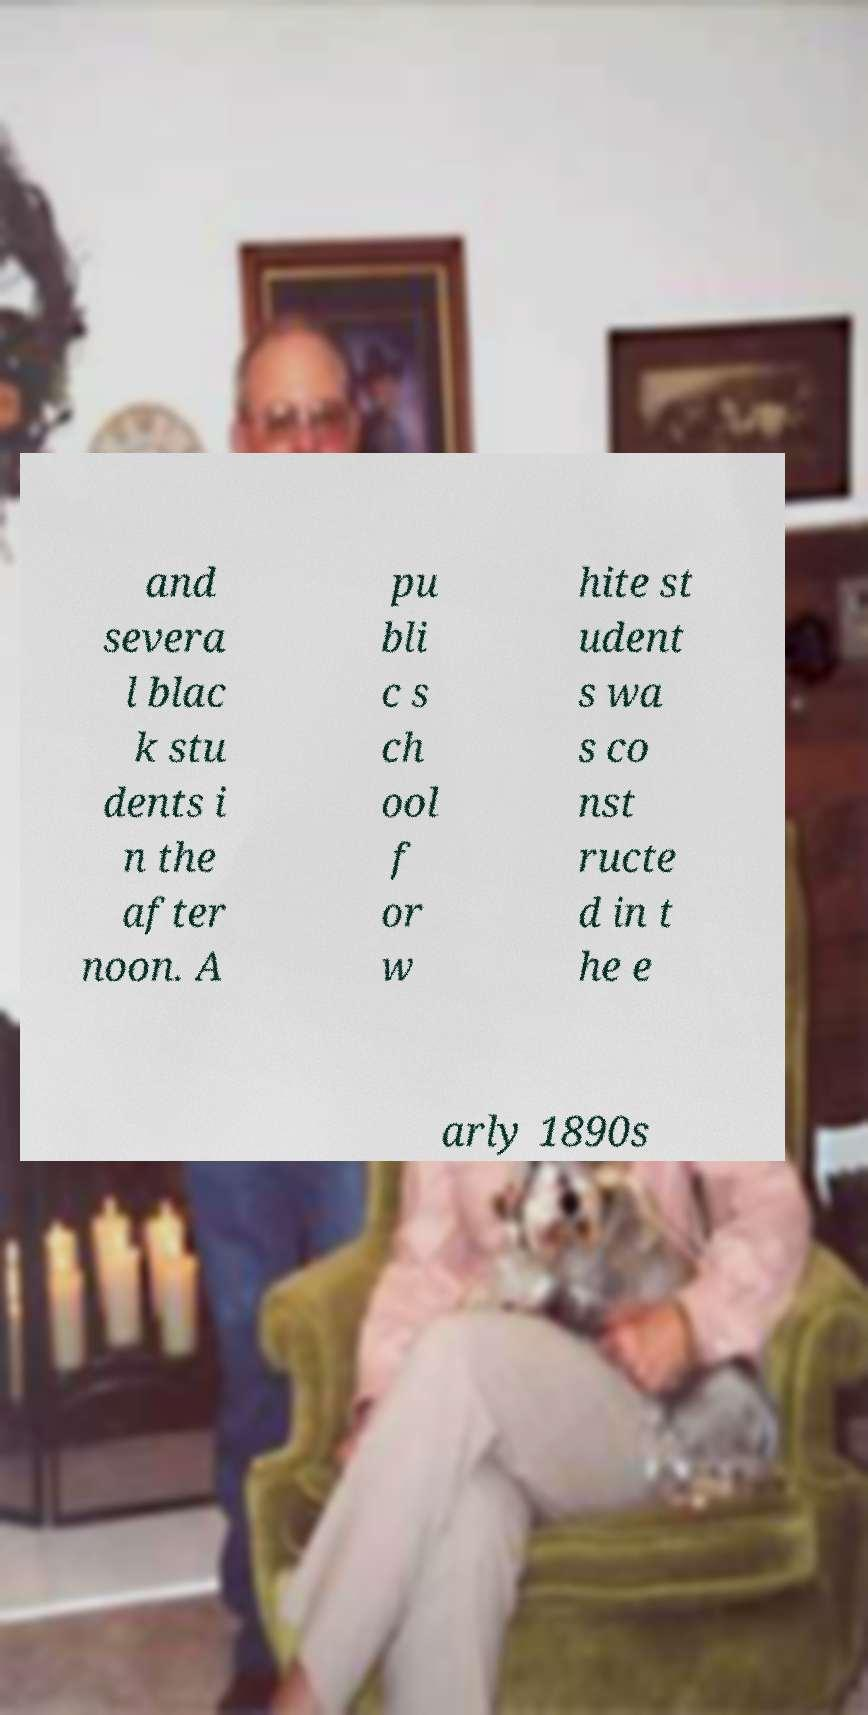For documentation purposes, I need the text within this image transcribed. Could you provide that? and severa l blac k stu dents i n the after noon. A pu bli c s ch ool f or w hite st udent s wa s co nst ructe d in t he e arly 1890s 